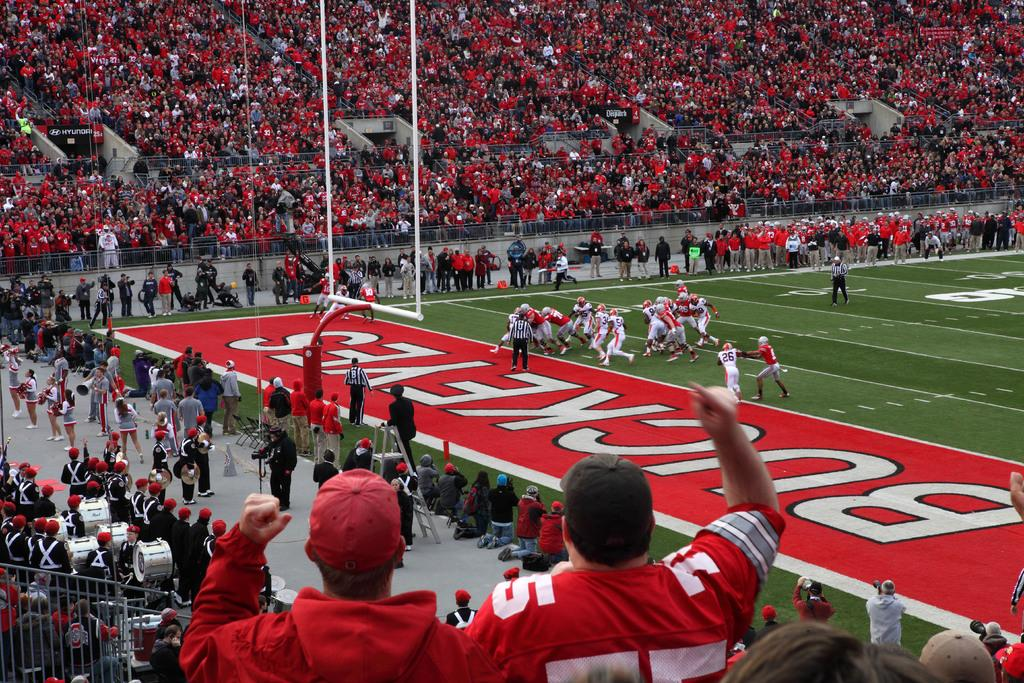Provide a one-sentence caption for the provided image. A stadium full of fans watching the Buckeyes football team. 